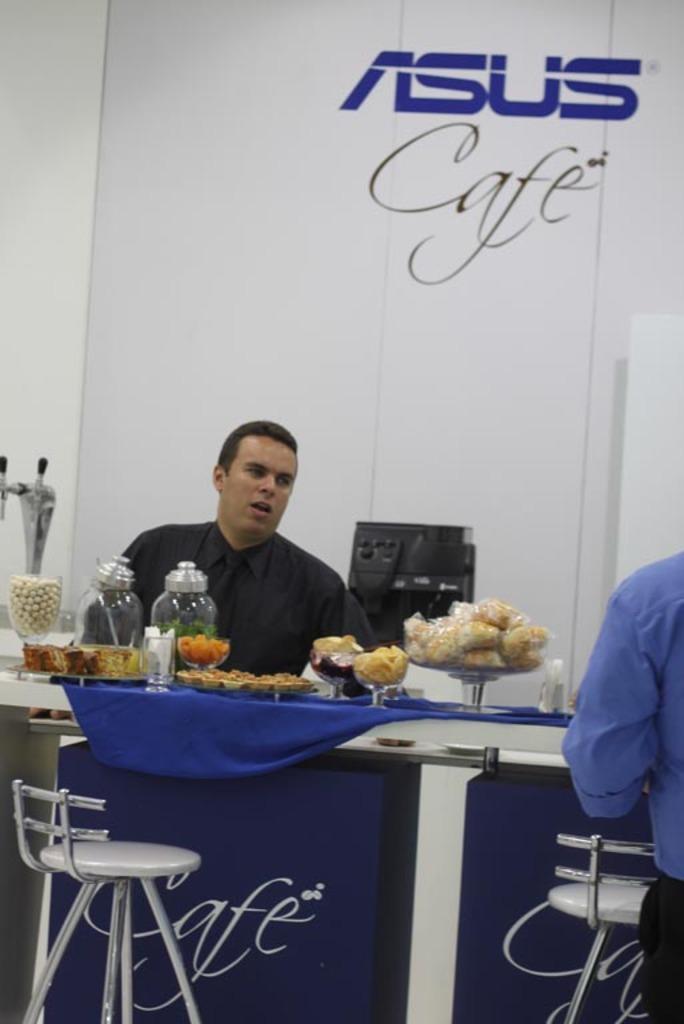In one or two sentences, can you explain what this image depicts? In this image i can see a man is sitting in front of a table on a stool. On the table I can see if there are few objects on it. 